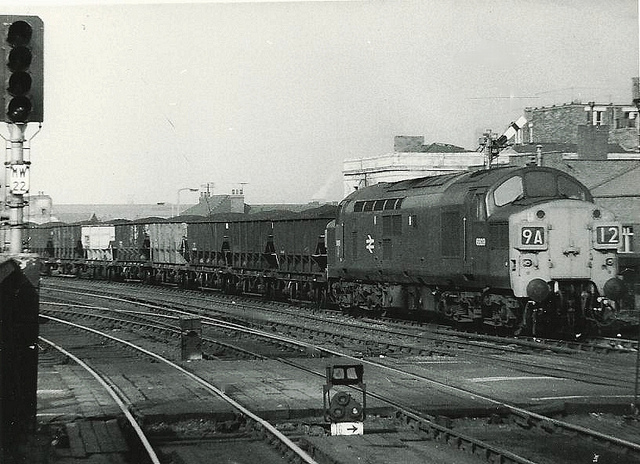Please transcribe the text in this image. 9A 12 